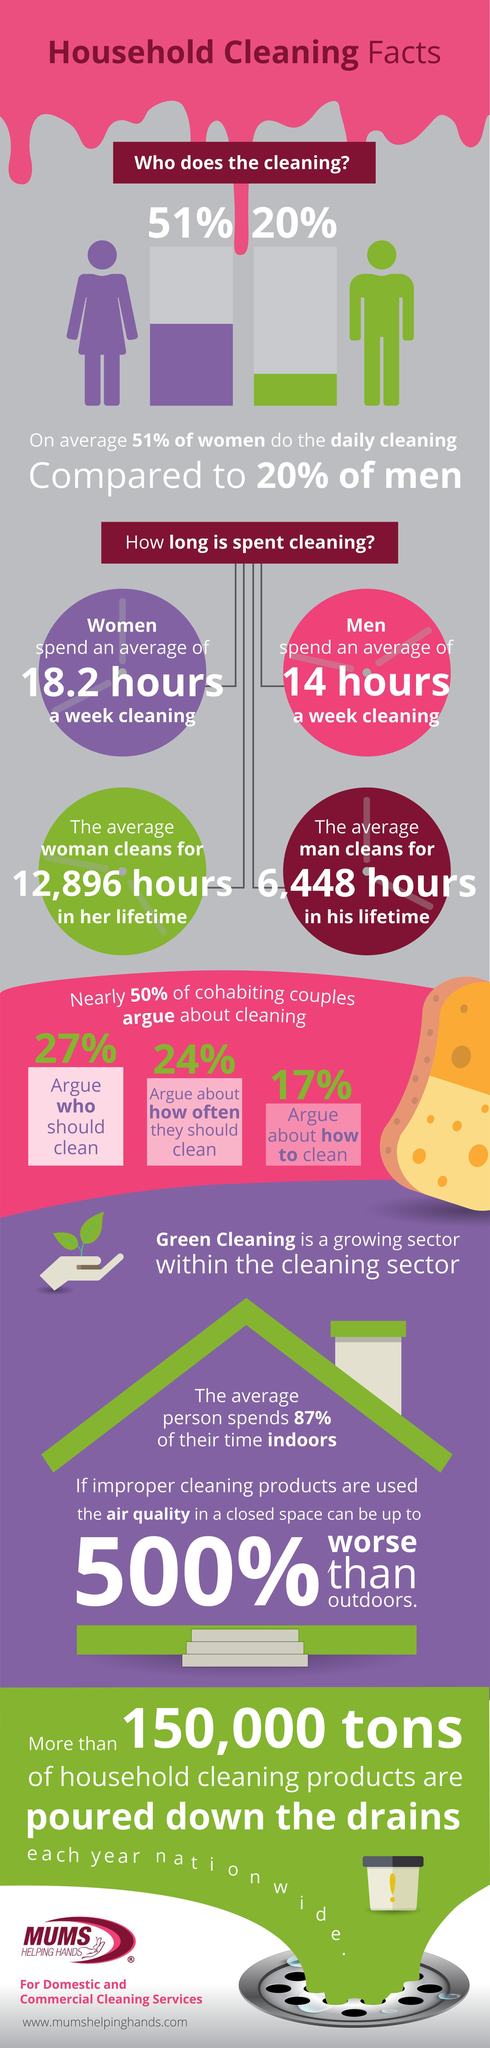What percentage of time people are spending outdoors?
Answer the question with a short phrase. 13 What is the average time a man spends for cleaning in his life time? 6,448 hours What percentage of couples argue about how often they should clean? 24% What percentage of couples do not argue whom should clean? 73 What percentage of couples argue about how to clean? 17% How much time men spends for cleaning in a week? 14 hours 